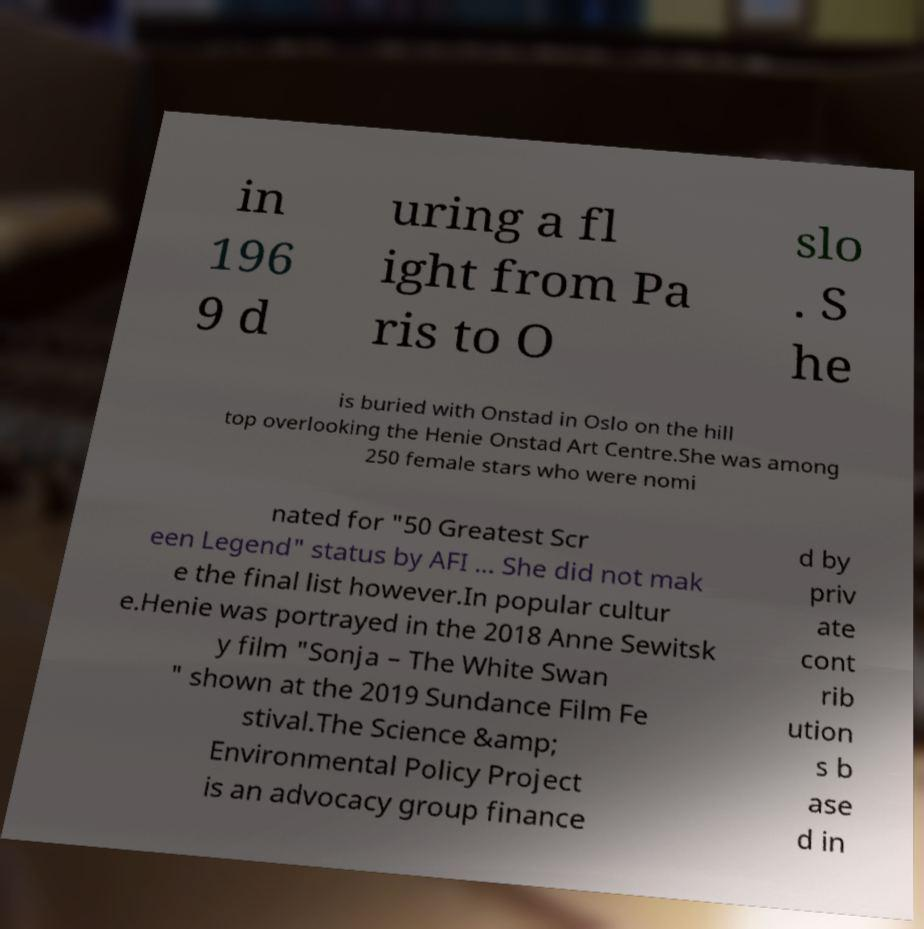Can you read and provide the text displayed in the image?This photo seems to have some interesting text. Can you extract and type it out for me? in 196 9 d uring a fl ight from Pa ris to O slo . S he is buried with Onstad in Oslo on the hill top overlooking the Henie Onstad Art Centre.She was among 250 female stars who were nomi nated for "50 Greatest Scr een Legend" status by AFI ... She did not mak e the final list however.In popular cultur e.Henie was portrayed in the 2018 Anne Sewitsk y film "Sonja – The White Swan " shown at the 2019 Sundance Film Fe stival.The Science &amp; Environmental Policy Project is an advocacy group finance d by priv ate cont rib ution s b ase d in 